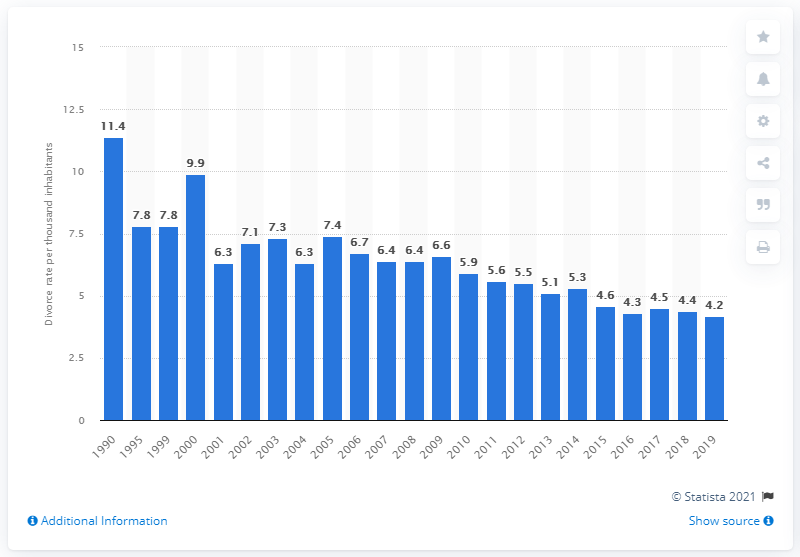Indicate a few pertinent items in this graphic. In 1990, the divorce rate in Nevada was 11.4. Nevada's divorce rate per thousand inhabitants in 2019 was 4.2, indicating a high rate of divorce in the state. 